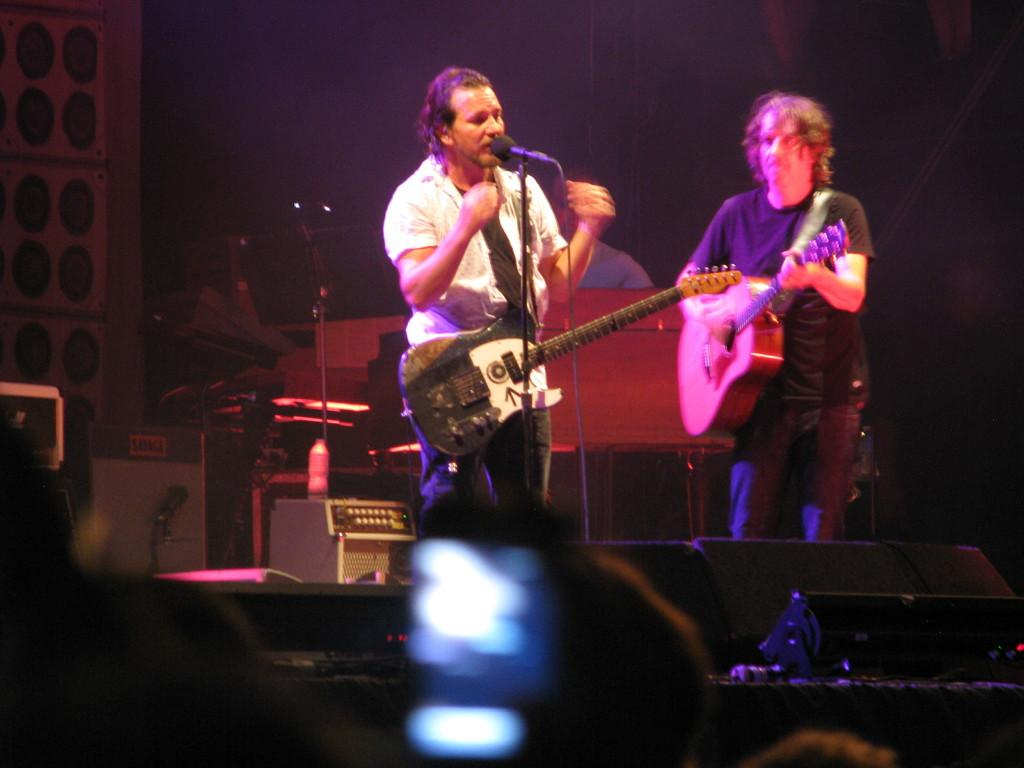How many people are in the image? There are two men standing in the image. What are the two men holding? The two men are holding guitars. What is the third person in the image doing? The third person is singing in the image. How is the singer amplifying his voice? The singer is using a microphone. What type of hateful message is being conveyed through the lyrics of the song in the image? There is no indication of any hateful message or lyrics in the image; it simply shows people playing and singing with guitars and a microphone. 